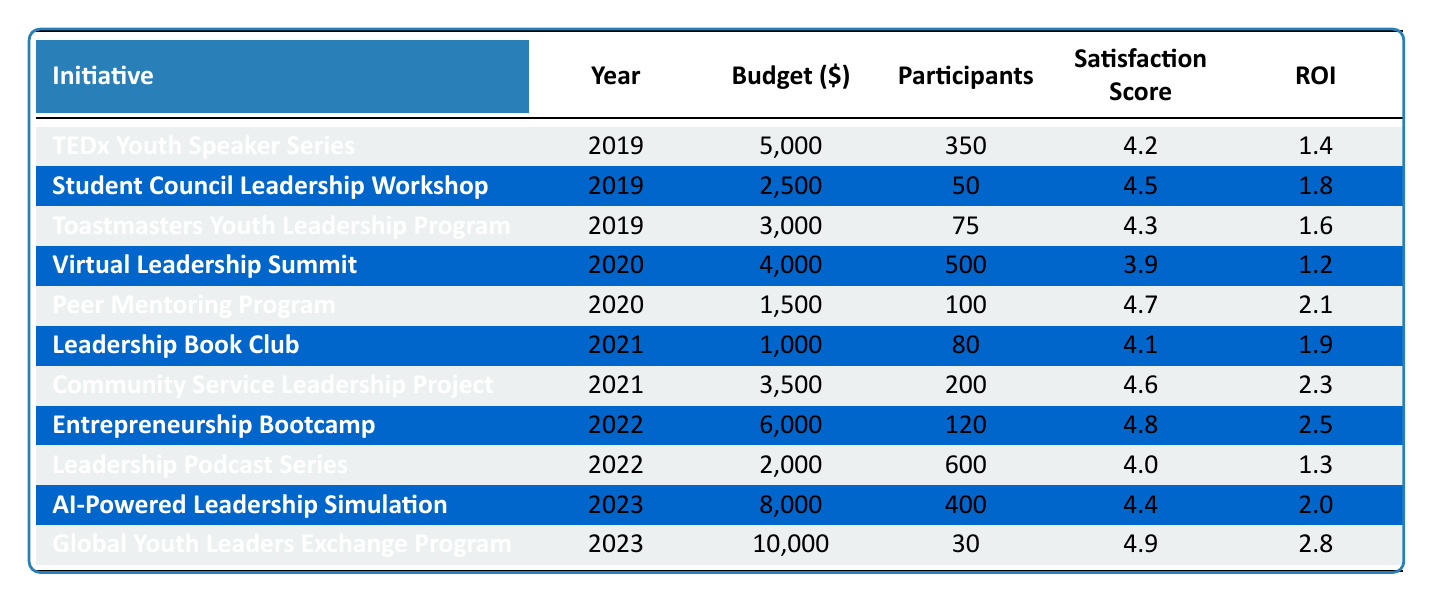What was the budget for the Community Service Leadership Project in 2021? The budget for the Community Service Leadership Project is listed in the table under the 2021 row. It shows a budget of 3500.
Answer: 3500 Which initiative had the highest Satisfaction Score in 2022? In 2022, the initiatives and their Satisfaction Scores are: Entrepreneurship Bootcamp (4.8) and Leadership Podcast Series (4.0). Comparing these, Entrepreneurship Bootcamp has the highest score of 4.8.
Answer: 4.8 What is the average ROI for all initiatives in 2023? The ROIs for 2023 are 2.0 (AI-Powered Leadership Simulation) and 2.8 (Global Youth Leaders Exchange Program). Adding these, we get 2.0 + 2.8 = 4.8. Then, we divide by the number of initiatives (2) to find the average: 4.8 / 2 = 2.4.
Answer: 2.4 Did more participants attend the Virtual Leadership Summit or the Entrepreneurship Bootcamp? The Virtual Leadership Summit had 500 participants, while the Entrepreneurship Bootcamp had 120 participants according to the table. Clearly, the Virtual Leadership Summit had more participants.
Answer: Yes In which year was the total budget for leadership initiatives the highest, and what was that budget? Adding the budgets for each year: 2019: 5000 + 2500 + 3000 = 10500, 2020: 4000 + 1500 = 5500, 2021: 1000 + 3500 = 4500, 2022: 6000 + 2000 = 8000, 2023: 8000 + 10000 = 18000. The highest total budget is 18000 in 2023.
Answer: 2023, 18000 How many initiatives had an ROI greater than 2.0? Looking at the table, the initiatives with ROI greater than 2.0 are: Peer Mentoring Program (2.1), Community Service Leadership Project (2.3), Entrepreneurship Bootcamp (2.5), AI-Powered Leadership Simulation (2.0), and Global Youth Leaders Exchange Program (2.8). This totals 4 initiatives.
Answer: 4 